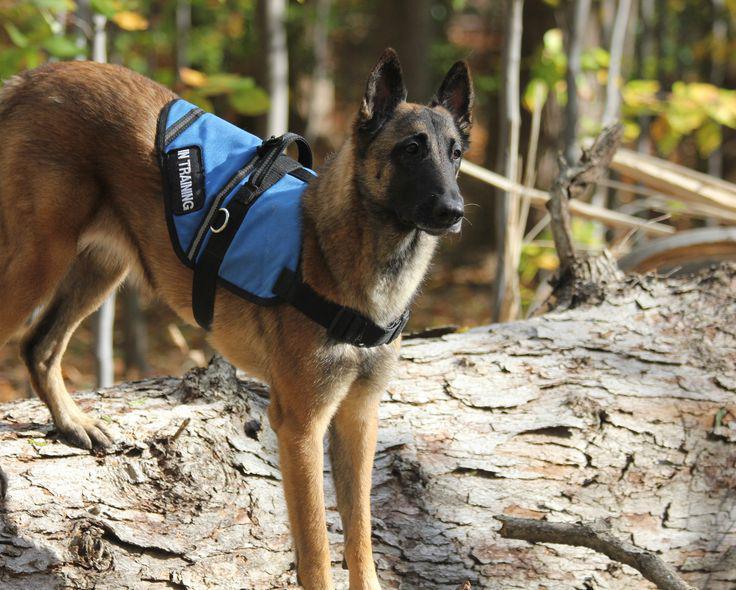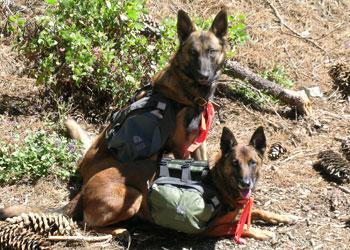The first image is the image on the left, the second image is the image on the right. Assess this claim about the two images: "There is a single human in the pair of images.". Correct or not? Answer yes or no. No. The first image is the image on the left, the second image is the image on the right. For the images displayed, is the sentence "One image shows a german shepherd in a harness vest sitting upright, and the othe image shows a man in padded pants holding a stick near a dog." factually correct? Answer yes or no. No. 